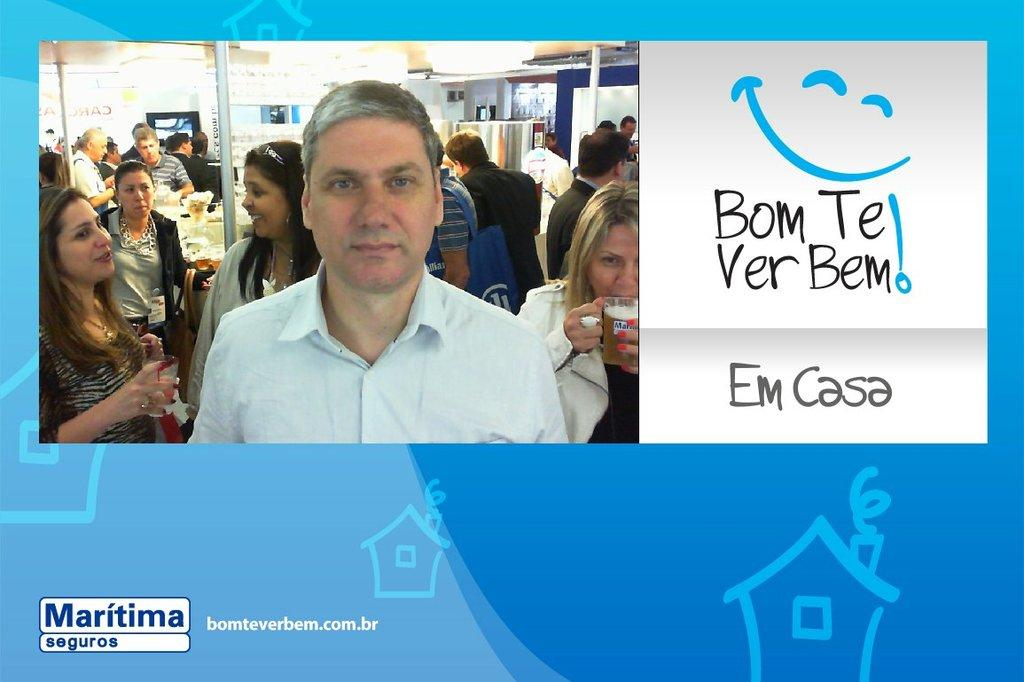What type of visual is the image in question? The image is a poster. What can be found on the poster besides images? There is text on the poster. What type of image is featured on the poster? There is an image of a house on the poster. What other types of images are present on the poster? There are images of people, places, and things on the poster. How many times did the cast attempt to wash the poster before it was hung up? There is no mention of a cast or any attempts to wash the poster in the provided facts. The poster is simply described as having text and various images. 